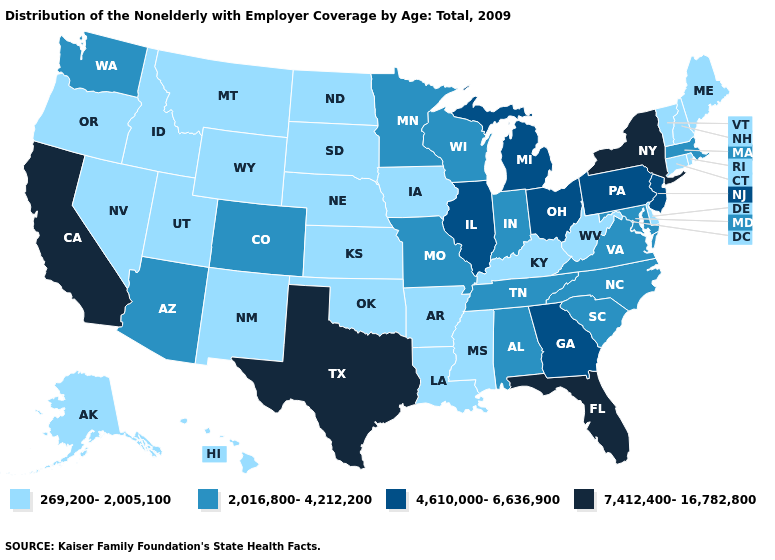Which states have the lowest value in the West?
Keep it brief. Alaska, Hawaii, Idaho, Montana, Nevada, New Mexico, Oregon, Utah, Wyoming. What is the value of Delaware?
Answer briefly. 269,200-2,005,100. Does Mississippi have the lowest value in the South?
Write a very short answer. Yes. What is the lowest value in states that border Connecticut?
Give a very brief answer. 269,200-2,005,100. Which states hav the highest value in the South?
Keep it brief. Florida, Texas. Among the states that border Missouri , does Illinois have the lowest value?
Give a very brief answer. No. Name the states that have a value in the range 4,610,000-6,636,900?
Concise answer only. Georgia, Illinois, Michigan, New Jersey, Ohio, Pennsylvania. Does Alaska have a lower value than California?
Keep it brief. Yes. What is the value of South Dakota?
Concise answer only. 269,200-2,005,100. Name the states that have a value in the range 269,200-2,005,100?
Concise answer only. Alaska, Arkansas, Connecticut, Delaware, Hawaii, Idaho, Iowa, Kansas, Kentucky, Louisiana, Maine, Mississippi, Montana, Nebraska, Nevada, New Hampshire, New Mexico, North Dakota, Oklahoma, Oregon, Rhode Island, South Dakota, Utah, Vermont, West Virginia, Wyoming. What is the value of Arkansas?
Answer briefly. 269,200-2,005,100. What is the lowest value in the USA?
Be succinct. 269,200-2,005,100. What is the lowest value in the South?
Concise answer only. 269,200-2,005,100. What is the highest value in states that border Minnesota?
Short answer required. 2,016,800-4,212,200. Among the states that border Indiana , does Kentucky have the highest value?
Answer briefly. No. 